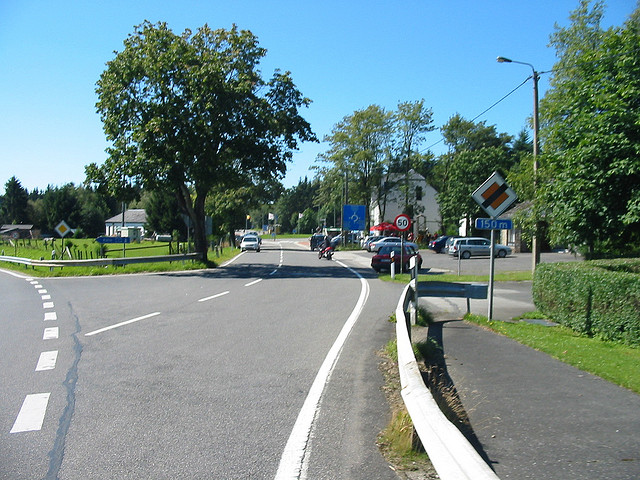Extract all visible text content from this image. 60 150 